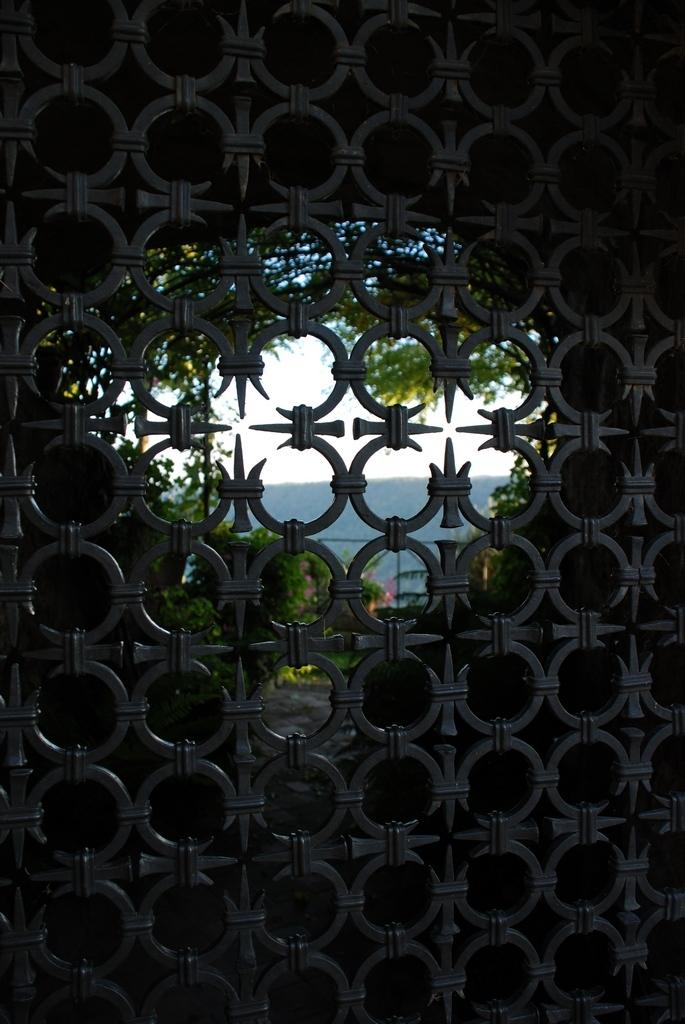What is the main subject in the image? There is a structure in the image. What can be seen outside the structure? There are trees visible outside the structure. What is visible in the background of the image? The sky is visible in the image. What type of popcorn is being used as a sail to guide the structure in the image? There is no popcorn, sail, or guiding element present in the image. 